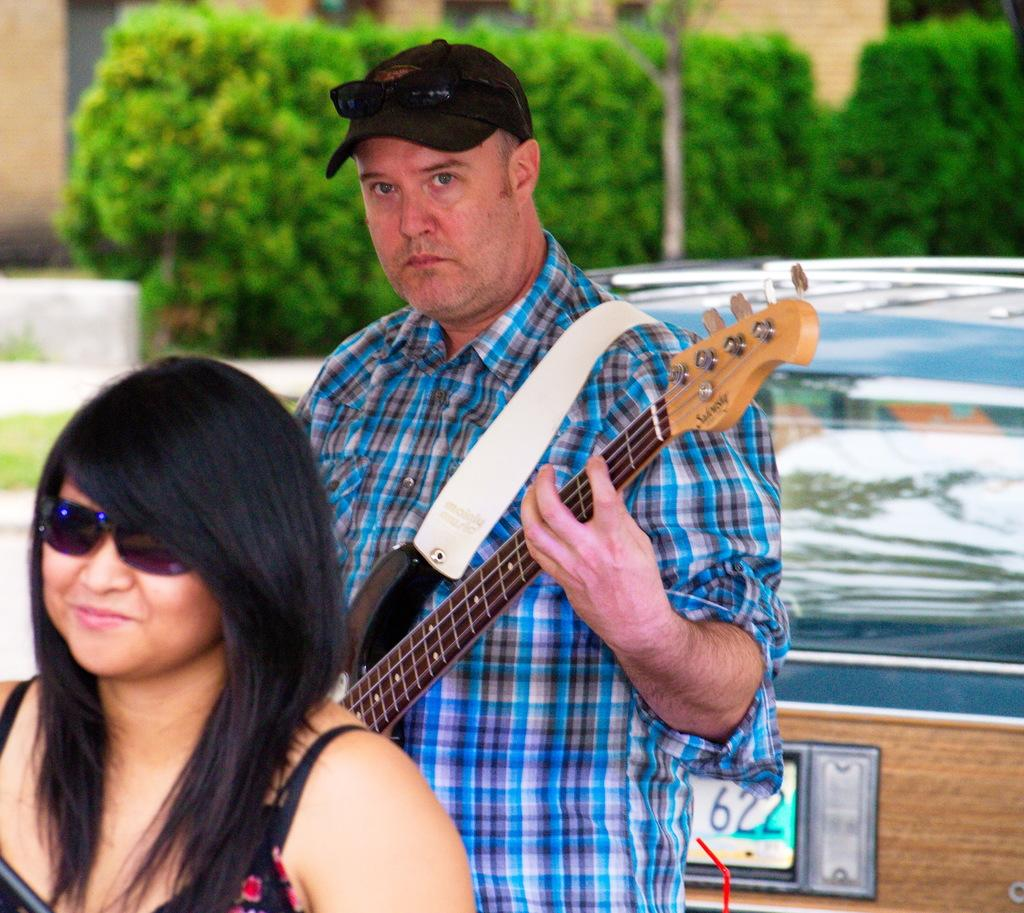What is the person in the image doing? The person is standing and playing the guitar. Can you describe the woman in the image? The woman is standing in front of the person playing the guitar. What can be seen in the background of the image? There are trees visible at the back of the image. How many babies are visible in the image? There are no babies present in the image. What type of stomach ailment does the person playing the guitar have? There is no information about any stomach ailments in the image. 